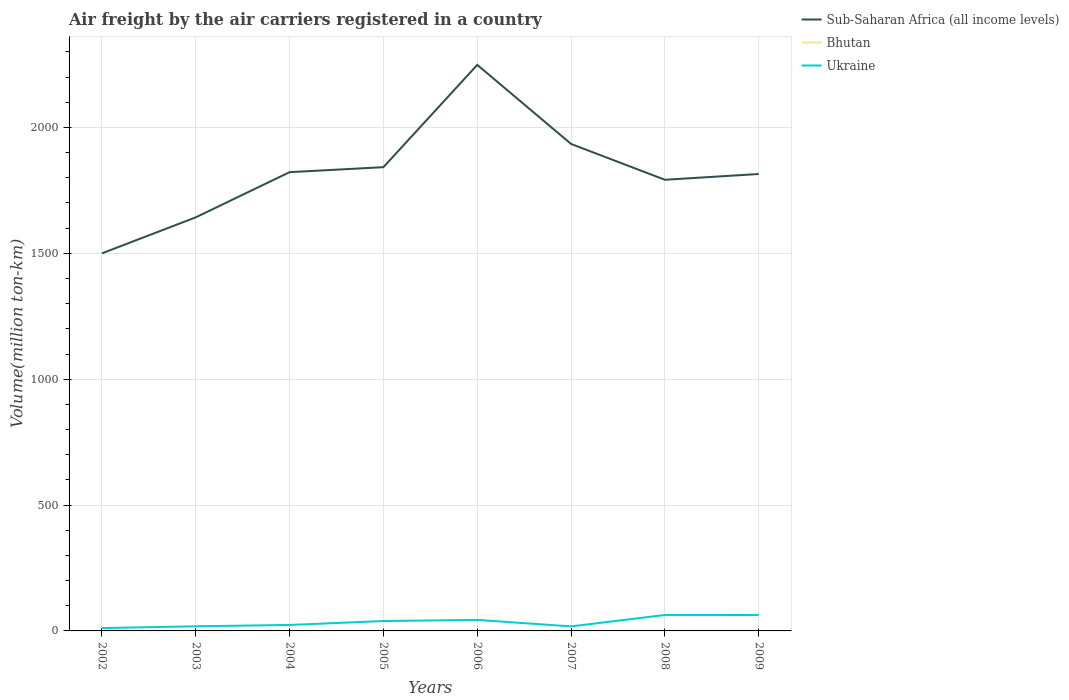Across all years, what is the maximum volume of the air carriers in Sub-Saharan Africa (all income levels)?
Offer a very short reply. 1499.87. In which year was the volume of the air carriers in Bhutan maximum?
Your answer should be compact. 2002. What is the total volume of the air carriers in Sub-Saharan Africa (all income levels) in the graph?
Offer a very short reply. -22.99. What is the difference between the highest and the second highest volume of the air carriers in Ukraine?
Provide a short and direct response. 52.08. What is the difference between the highest and the lowest volume of the air carriers in Bhutan?
Provide a short and direct response. 2. Is the volume of the air carriers in Ukraine strictly greater than the volume of the air carriers in Bhutan over the years?
Provide a succinct answer. No. How many lines are there?
Offer a very short reply. 3. How many years are there in the graph?
Provide a succinct answer. 8. Does the graph contain grids?
Provide a short and direct response. Yes. Where does the legend appear in the graph?
Your answer should be very brief. Top right. How are the legend labels stacked?
Provide a short and direct response. Vertical. What is the title of the graph?
Give a very brief answer. Air freight by the air carriers registered in a country. What is the label or title of the Y-axis?
Your response must be concise. Volume(million ton-km). What is the Volume(million ton-km) in Sub-Saharan Africa (all income levels) in 2002?
Your answer should be compact. 1499.87. What is the Volume(million ton-km) in Ukraine in 2002?
Provide a short and direct response. 11.28. What is the Volume(million ton-km) in Sub-Saharan Africa (all income levels) in 2003?
Your answer should be compact. 1642.87. What is the Volume(million ton-km) of Bhutan in 2003?
Keep it short and to the point. 0.21. What is the Volume(million ton-km) of Ukraine in 2003?
Your answer should be very brief. 18.36. What is the Volume(million ton-km) in Sub-Saharan Africa (all income levels) in 2004?
Your answer should be very brief. 1822.41. What is the Volume(million ton-km) in Bhutan in 2004?
Your answer should be compact. 0.25. What is the Volume(million ton-km) in Ukraine in 2004?
Your answer should be compact. 23.73. What is the Volume(million ton-km) of Sub-Saharan Africa (all income levels) in 2005?
Your answer should be compact. 1842.22. What is the Volume(million ton-km) of Bhutan in 2005?
Your answer should be very brief. 0.25. What is the Volume(million ton-km) in Ukraine in 2005?
Provide a short and direct response. 39.29. What is the Volume(million ton-km) in Sub-Saharan Africa (all income levels) in 2006?
Provide a succinct answer. 2248.58. What is the Volume(million ton-km) of Bhutan in 2006?
Give a very brief answer. 0.26. What is the Volume(million ton-km) in Ukraine in 2006?
Your response must be concise. 43.76. What is the Volume(million ton-km) in Sub-Saharan Africa (all income levels) in 2007?
Offer a terse response. 1934.43. What is the Volume(million ton-km) of Bhutan in 2007?
Your response must be concise. 0.28. What is the Volume(million ton-km) of Ukraine in 2007?
Provide a short and direct response. 18.01. What is the Volume(million ton-km) in Sub-Saharan Africa (all income levels) in 2008?
Make the answer very short. 1792.12. What is the Volume(million ton-km) of Bhutan in 2008?
Provide a succinct answer. 0.26. What is the Volume(million ton-km) in Ukraine in 2008?
Offer a terse response. 63.36. What is the Volume(million ton-km) of Sub-Saharan Africa (all income levels) in 2009?
Offer a terse response. 1815.11. What is the Volume(million ton-km) of Bhutan in 2009?
Give a very brief answer. 0.45. What is the Volume(million ton-km) in Ukraine in 2009?
Your response must be concise. 63.23. Across all years, what is the maximum Volume(million ton-km) in Sub-Saharan Africa (all income levels)?
Your answer should be compact. 2248.58. Across all years, what is the maximum Volume(million ton-km) in Bhutan?
Provide a succinct answer. 0.45. Across all years, what is the maximum Volume(million ton-km) of Ukraine?
Your answer should be very brief. 63.36. Across all years, what is the minimum Volume(million ton-km) in Sub-Saharan Africa (all income levels)?
Ensure brevity in your answer.  1499.87. Across all years, what is the minimum Volume(million ton-km) in Bhutan?
Make the answer very short. 0.2. Across all years, what is the minimum Volume(million ton-km) of Ukraine?
Make the answer very short. 11.28. What is the total Volume(million ton-km) of Sub-Saharan Africa (all income levels) in the graph?
Offer a terse response. 1.46e+04. What is the total Volume(million ton-km) of Bhutan in the graph?
Ensure brevity in your answer.  2.16. What is the total Volume(million ton-km) of Ukraine in the graph?
Provide a short and direct response. 281.03. What is the difference between the Volume(million ton-km) of Sub-Saharan Africa (all income levels) in 2002 and that in 2003?
Give a very brief answer. -143. What is the difference between the Volume(million ton-km) of Bhutan in 2002 and that in 2003?
Your answer should be compact. -0.01. What is the difference between the Volume(million ton-km) in Ukraine in 2002 and that in 2003?
Offer a very short reply. -7.08. What is the difference between the Volume(million ton-km) of Sub-Saharan Africa (all income levels) in 2002 and that in 2004?
Make the answer very short. -322.53. What is the difference between the Volume(million ton-km) of Bhutan in 2002 and that in 2004?
Your answer should be compact. -0.05. What is the difference between the Volume(million ton-km) of Ukraine in 2002 and that in 2004?
Keep it short and to the point. -12.45. What is the difference between the Volume(million ton-km) in Sub-Saharan Africa (all income levels) in 2002 and that in 2005?
Provide a succinct answer. -342.35. What is the difference between the Volume(million ton-km) of Bhutan in 2002 and that in 2005?
Provide a short and direct response. -0.05. What is the difference between the Volume(million ton-km) in Ukraine in 2002 and that in 2005?
Make the answer very short. -28.01. What is the difference between the Volume(million ton-km) in Sub-Saharan Africa (all income levels) in 2002 and that in 2006?
Ensure brevity in your answer.  -748.71. What is the difference between the Volume(million ton-km) in Bhutan in 2002 and that in 2006?
Offer a very short reply. -0.06. What is the difference between the Volume(million ton-km) in Ukraine in 2002 and that in 2006?
Your answer should be compact. -32.48. What is the difference between the Volume(million ton-km) of Sub-Saharan Africa (all income levels) in 2002 and that in 2007?
Provide a short and direct response. -434.56. What is the difference between the Volume(million ton-km) in Bhutan in 2002 and that in 2007?
Give a very brief answer. -0.08. What is the difference between the Volume(million ton-km) of Ukraine in 2002 and that in 2007?
Your answer should be very brief. -6.73. What is the difference between the Volume(million ton-km) in Sub-Saharan Africa (all income levels) in 2002 and that in 2008?
Provide a short and direct response. -292.24. What is the difference between the Volume(million ton-km) of Bhutan in 2002 and that in 2008?
Make the answer very short. -0.06. What is the difference between the Volume(million ton-km) in Ukraine in 2002 and that in 2008?
Your response must be concise. -52.08. What is the difference between the Volume(million ton-km) in Sub-Saharan Africa (all income levels) in 2002 and that in 2009?
Your answer should be very brief. -315.24. What is the difference between the Volume(million ton-km) of Bhutan in 2002 and that in 2009?
Offer a very short reply. -0.25. What is the difference between the Volume(million ton-km) in Ukraine in 2002 and that in 2009?
Your response must be concise. -51.95. What is the difference between the Volume(million ton-km) of Sub-Saharan Africa (all income levels) in 2003 and that in 2004?
Your response must be concise. -179.54. What is the difference between the Volume(million ton-km) in Bhutan in 2003 and that in 2004?
Ensure brevity in your answer.  -0.04. What is the difference between the Volume(million ton-km) of Ukraine in 2003 and that in 2004?
Offer a terse response. -5.38. What is the difference between the Volume(million ton-km) of Sub-Saharan Africa (all income levels) in 2003 and that in 2005?
Provide a succinct answer. -199.35. What is the difference between the Volume(million ton-km) in Bhutan in 2003 and that in 2005?
Offer a very short reply. -0.04. What is the difference between the Volume(million ton-km) in Ukraine in 2003 and that in 2005?
Give a very brief answer. -20.93. What is the difference between the Volume(million ton-km) in Sub-Saharan Africa (all income levels) in 2003 and that in 2006?
Provide a short and direct response. -605.71. What is the difference between the Volume(million ton-km) of Bhutan in 2003 and that in 2006?
Give a very brief answer. -0.05. What is the difference between the Volume(million ton-km) in Ukraine in 2003 and that in 2006?
Ensure brevity in your answer.  -25.4. What is the difference between the Volume(million ton-km) in Sub-Saharan Africa (all income levels) in 2003 and that in 2007?
Provide a succinct answer. -291.56. What is the difference between the Volume(million ton-km) of Bhutan in 2003 and that in 2007?
Give a very brief answer. -0.07. What is the difference between the Volume(million ton-km) in Ukraine in 2003 and that in 2007?
Give a very brief answer. 0.35. What is the difference between the Volume(million ton-km) of Sub-Saharan Africa (all income levels) in 2003 and that in 2008?
Give a very brief answer. -149.25. What is the difference between the Volume(million ton-km) in Bhutan in 2003 and that in 2008?
Offer a very short reply. -0.05. What is the difference between the Volume(million ton-km) of Ukraine in 2003 and that in 2008?
Offer a very short reply. -45. What is the difference between the Volume(million ton-km) of Sub-Saharan Africa (all income levels) in 2003 and that in 2009?
Provide a short and direct response. -172.24. What is the difference between the Volume(million ton-km) of Bhutan in 2003 and that in 2009?
Provide a short and direct response. -0.24. What is the difference between the Volume(million ton-km) in Ukraine in 2003 and that in 2009?
Make the answer very short. -44.87. What is the difference between the Volume(million ton-km) in Sub-Saharan Africa (all income levels) in 2004 and that in 2005?
Provide a succinct answer. -19.82. What is the difference between the Volume(million ton-km) in Bhutan in 2004 and that in 2005?
Provide a succinct answer. -0.01. What is the difference between the Volume(million ton-km) of Ukraine in 2004 and that in 2005?
Your response must be concise. -15.56. What is the difference between the Volume(million ton-km) in Sub-Saharan Africa (all income levels) in 2004 and that in 2006?
Make the answer very short. -426.18. What is the difference between the Volume(million ton-km) of Bhutan in 2004 and that in 2006?
Your answer should be compact. -0.02. What is the difference between the Volume(million ton-km) of Ukraine in 2004 and that in 2006?
Your answer should be compact. -20.03. What is the difference between the Volume(million ton-km) in Sub-Saharan Africa (all income levels) in 2004 and that in 2007?
Your response must be concise. -112.02. What is the difference between the Volume(million ton-km) in Bhutan in 2004 and that in 2007?
Ensure brevity in your answer.  -0.03. What is the difference between the Volume(million ton-km) of Ukraine in 2004 and that in 2007?
Your response must be concise. 5.72. What is the difference between the Volume(million ton-km) of Sub-Saharan Africa (all income levels) in 2004 and that in 2008?
Your answer should be very brief. 30.29. What is the difference between the Volume(million ton-km) in Bhutan in 2004 and that in 2008?
Your response must be concise. -0.02. What is the difference between the Volume(million ton-km) of Ukraine in 2004 and that in 2008?
Ensure brevity in your answer.  -39.62. What is the difference between the Volume(million ton-km) in Sub-Saharan Africa (all income levels) in 2004 and that in 2009?
Offer a very short reply. 7.3. What is the difference between the Volume(million ton-km) of Bhutan in 2004 and that in 2009?
Provide a succinct answer. -0.2. What is the difference between the Volume(million ton-km) of Ukraine in 2004 and that in 2009?
Offer a terse response. -39.5. What is the difference between the Volume(million ton-km) of Sub-Saharan Africa (all income levels) in 2005 and that in 2006?
Your response must be concise. -406.36. What is the difference between the Volume(million ton-km) of Bhutan in 2005 and that in 2006?
Make the answer very short. -0.01. What is the difference between the Volume(million ton-km) in Ukraine in 2005 and that in 2006?
Provide a succinct answer. -4.47. What is the difference between the Volume(million ton-km) of Sub-Saharan Africa (all income levels) in 2005 and that in 2007?
Provide a short and direct response. -92.2. What is the difference between the Volume(million ton-km) of Bhutan in 2005 and that in 2007?
Provide a succinct answer. -0.03. What is the difference between the Volume(million ton-km) of Ukraine in 2005 and that in 2007?
Provide a succinct answer. 21.28. What is the difference between the Volume(million ton-km) of Sub-Saharan Africa (all income levels) in 2005 and that in 2008?
Keep it short and to the point. 50.11. What is the difference between the Volume(million ton-km) of Bhutan in 2005 and that in 2008?
Provide a succinct answer. -0.01. What is the difference between the Volume(million ton-km) in Ukraine in 2005 and that in 2008?
Your answer should be very brief. -24.07. What is the difference between the Volume(million ton-km) of Sub-Saharan Africa (all income levels) in 2005 and that in 2009?
Make the answer very short. 27.11. What is the difference between the Volume(million ton-km) in Bhutan in 2005 and that in 2009?
Your answer should be very brief. -0.2. What is the difference between the Volume(million ton-km) of Ukraine in 2005 and that in 2009?
Ensure brevity in your answer.  -23.94. What is the difference between the Volume(million ton-km) in Sub-Saharan Africa (all income levels) in 2006 and that in 2007?
Make the answer very short. 314.16. What is the difference between the Volume(million ton-km) of Bhutan in 2006 and that in 2007?
Your answer should be compact. -0.02. What is the difference between the Volume(million ton-km) in Ukraine in 2006 and that in 2007?
Offer a terse response. 25.75. What is the difference between the Volume(million ton-km) of Sub-Saharan Africa (all income levels) in 2006 and that in 2008?
Make the answer very short. 456.47. What is the difference between the Volume(million ton-km) in Bhutan in 2006 and that in 2008?
Give a very brief answer. -0. What is the difference between the Volume(million ton-km) of Ukraine in 2006 and that in 2008?
Provide a short and direct response. -19.6. What is the difference between the Volume(million ton-km) in Sub-Saharan Africa (all income levels) in 2006 and that in 2009?
Your answer should be very brief. 433.48. What is the difference between the Volume(million ton-km) of Bhutan in 2006 and that in 2009?
Keep it short and to the point. -0.18. What is the difference between the Volume(million ton-km) of Ukraine in 2006 and that in 2009?
Provide a short and direct response. -19.47. What is the difference between the Volume(million ton-km) in Sub-Saharan Africa (all income levels) in 2007 and that in 2008?
Keep it short and to the point. 142.31. What is the difference between the Volume(million ton-km) of Bhutan in 2007 and that in 2008?
Ensure brevity in your answer.  0.01. What is the difference between the Volume(million ton-km) in Ukraine in 2007 and that in 2008?
Provide a short and direct response. -45.35. What is the difference between the Volume(million ton-km) in Sub-Saharan Africa (all income levels) in 2007 and that in 2009?
Your answer should be very brief. 119.32. What is the difference between the Volume(million ton-km) of Bhutan in 2007 and that in 2009?
Provide a succinct answer. -0.17. What is the difference between the Volume(million ton-km) in Ukraine in 2007 and that in 2009?
Your answer should be very brief. -45.22. What is the difference between the Volume(million ton-km) in Sub-Saharan Africa (all income levels) in 2008 and that in 2009?
Keep it short and to the point. -22.99. What is the difference between the Volume(million ton-km) in Bhutan in 2008 and that in 2009?
Provide a short and direct response. -0.18. What is the difference between the Volume(million ton-km) of Ukraine in 2008 and that in 2009?
Your answer should be compact. 0.13. What is the difference between the Volume(million ton-km) of Sub-Saharan Africa (all income levels) in 2002 and the Volume(million ton-km) of Bhutan in 2003?
Give a very brief answer. 1499.66. What is the difference between the Volume(million ton-km) of Sub-Saharan Africa (all income levels) in 2002 and the Volume(million ton-km) of Ukraine in 2003?
Keep it short and to the point. 1481.51. What is the difference between the Volume(million ton-km) of Bhutan in 2002 and the Volume(million ton-km) of Ukraine in 2003?
Ensure brevity in your answer.  -18.16. What is the difference between the Volume(million ton-km) of Sub-Saharan Africa (all income levels) in 2002 and the Volume(million ton-km) of Bhutan in 2004?
Offer a terse response. 1499.63. What is the difference between the Volume(million ton-km) in Sub-Saharan Africa (all income levels) in 2002 and the Volume(million ton-km) in Ukraine in 2004?
Give a very brief answer. 1476.14. What is the difference between the Volume(million ton-km) of Bhutan in 2002 and the Volume(million ton-km) of Ukraine in 2004?
Your answer should be very brief. -23.53. What is the difference between the Volume(million ton-km) of Sub-Saharan Africa (all income levels) in 2002 and the Volume(million ton-km) of Bhutan in 2005?
Make the answer very short. 1499.62. What is the difference between the Volume(million ton-km) in Sub-Saharan Africa (all income levels) in 2002 and the Volume(million ton-km) in Ukraine in 2005?
Your answer should be very brief. 1460.58. What is the difference between the Volume(million ton-km) of Bhutan in 2002 and the Volume(million ton-km) of Ukraine in 2005?
Your answer should be compact. -39.09. What is the difference between the Volume(million ton-km) of Sub-Saharan Africa (all income levels) in 2002 and the Volume(million ton-km) of Bhutan in 2006?
Offer a very short reply. 1499.61. What is the difference between the Volume(million ton-km) of Sub-Saharan Africa (all income levels) in 2002 and the Volume(million ton-km) of Ukraine in 2006?
Your answer should be compact. 1456.11. What is the difference between the Volume(million ton-km) of Bhutan in 2002 and the Volume(million ton-km) of Ukraine in 2006?
Offer a terse response. -43.56. What is the difference between the Volume(million ton-km) in Sub-Saharan Africa (all income levels) in 2002 and the Volume(million ton-km) in Bhutan in 2007?
Your answer should be compact. 1499.59. What is the difference between the Volume(million ton-km) in Sub-Saharan Africa (all income levels) in 2002 and the Volume(million ton-km) in Ukraine in 2007?
Give a very brief answer. 1481.86. What is the difference between the Volume(million ton-km) in Bhutan in 2002 and the Volume(million ton-km) in Ukraine in 2007?
Your answer should be very brief. -17.81. What is the difference between the Volume(million ton-km) in Sub-Saharan Africa (all income levels) in 2002 and the Volume(million ton-km) in Bhutan in 2008?
Provide a short and direct response. 1499.61. What is the difference between the Volume(million ton-km) in Sub-Saharan Africa (all income levels) in 2002 and the Volume(million ton-km) in Ukraine in 2008?
Offer a very short reply. 1436.51. What is the difference between the Volume(million ton-km) of Bhutan in 2002 and the Volume(million ton-km) of Ukraine in 2008?
Offer a terse response. -63.16. What is the difference between the Volume(million ton-km) of Sub-Saharan Africa (all income levels) in 2002 and the Volume(million ton-km) of Bhutan in 2009?
Give a very brief answer. 1499.42. What is the difference between the Volume(million ton-km) in Sub-Saharan Africa (all income levels) in 2002 and the Volume(million ton-km) in Ukraine in 2009?
Offer a very short reply. 1436.64. What is the difference between the Volume(million ton-km) in Bhutan in 2002 and the Volume(million ton-km) in Ukraine in 2009?
Offer a terse response. -63.03. What is the difference between the Volume(million ton-km) of Sub-Saharan Africa (all income levels) in 2003 and the Volume(million ton-km) of Bhutan in 2004?
Your answer should be very brief. 1642.62. What is the difference between the Volume(million ton-km) in Sub-Saharan Africa (all income levels) in 2003 and the Volume(million ton-km) in Ukraine in 2004?
Offer a very short reply. 1619.13. What is the difference between the Volume(million ton-km) in Bhutan in 2003 and the Volume(million ton-km) in Ukraine in 2004?
Ensure brevity in your answer.  -23.52. What is the difference between the Volume(million ton-km) of Sub-Saharan Africa (all income levels) in 2003 and the Volume(million ton-km) of Bhutan in 2005?
Give a very brief answer. 1642.62. What is the difference between the Volume(million ton-km) of Sub-Saharan Africa (all income levels) in 2003 and the Volume(million ton-km) of Ukraine in 2005?
Offer a very short reply. 1603.58. What is the difference between the Volume(million ton-km) of Bhutan in 2003 and the Volume(million ton-km) of Ukraine in 2005?
Your answer should be compact. -39.08. What is the difference between the Volume(million ton-km) in Sub-Saharan Africa (all income levels) in 2003 and the Volume(million ton-km) in Bhutan in 2006?
Give a very brief answer. 1642.61. What is the difference between the Volume(million ton-km) of Sub-Saharan Africa (all income levels) in 2003 and the Volume(million ton-km) of Ukraine in 2006?
Make the answer very short. 1599.11. What is the difference between the Volume(million ton-km) of Bhutan in 2003 and the Volume(million ton-km) of Ukraine in 2006?
Your answer should be very brief. -43.55. What is the difference between the Volume(million ton-km) of Sub-Saharan Africa (all income levels) in 2003 and the Volume(million ton-km) of Bhutan in 2007?
Ensure brevity in your answer.  1642.59. What is the difference between the Volume(million ton-km) of Sub-Saharan Africa (all income levels) in 2003 and the Volume(million ton-km) of Ukraine in 2007?
Offer a very short reply. 1624.86. What is the difference between the Volume(million ton-km) of Bhutan in 2003 and the Volume(million ton-km) of Ukraine in 2007?
Offer a very short reply. -17.8. What is the difference between the Volume(million ton-km) of Sub-Saharan Africa (all income levels) in 2003 and the Volume(million ton-km) of Bhutan in 2008?
Keep it short and to the point. 1642.61. What is the difference between the Volume(million ton-km) of Sub-Saharan Africa (all income levels) in 2003 and the Volume(million ton-km) of Ukraine in 2008?
Provide a short and direct response. 1579.51. What is the difference between the Volume(million ton-km) of Bhutan in 2003 and the Volume(million ton-km) of Ukraine in 2008?
Your response must be concise. -63.15. What is the difference between the Volume(million ton-km) of Sub-Saharan Africa (all income levels) in 2003 and the Volume(million ton-km) of Bhutan in 2009?
Ensure brevity in your answer.  1642.42. What is the difference between the Volume(million ton-km) in Sub-Saharan Africa (all income levels) in 2003 and the Volume(million ton-km) in Ukraine in 2009?
Your answer should be compact. 1579.64. What is the difference between the Volume(million ton-km) in Bhutan in 2003 and the Volume(million ton-km) in Ukraine in 2009?
Your answer should be very brief. -63.02. What is the difference between the Volume(million ton-km) in Sub-Saharan Africa (all income levels) in 2004 and the Volume(million ton-km) in Bhutan in 2005?
Ensure brevity in your answer.  1822.15. What is the difference between the Volume(million ton-km) of Sub-Saharan Africa (all income levels) in 2004 and the Volume(million ton-km) of Ukraine in 2005?
Your response must be concise. 1783.11. What is the difference between the Volume(million ton-km) of Bhutan in 2004 and the Volume(million ton-km) of Ukraine in 2005?
Your answer should be compact. -39.05. What is the difference between the Volume(million ton-km) of Sub-Saharan Africa (all income levels) in 2004 and the Volume(million ton-km) of Bhutan in 2006?
Keep it short and to the point. 1822.14. What is the difference between the Volume(million ton-km) in Sub-Saharan Africa (all income levels) in 2004 and the Volume(million ton-km) in Ukraine in 2006?
Your answer should be very brief. 1778.64. What is the difference between the Volume(million ton-km) of Bhutan in 2004 and the Volume(million ton-km) of Ukraine in 2006?
Offer a very short reply. -43.52. What is the difference between the Volume(million ton-km) of Sub-Saharan Africa (all income levels) in 2004 and the Volume(million ton-km) of Bhutan in 2007?
Ensure brevity in your answer.  1822.13. What is the difference between the Volume(million ton-km) of Sub-Saharan Africa (all income levels) in 2004 and the Volume(million ton-km) of Ukraine in 2007?
Your response must be concise. 1804.39. What is the difference between the Volume(million ton-km) in Bhutan in 2004 and the Volume(million ton-km) in Ukraine in 2007?
Your answer should be very brief. -17.77. What is the difference between the Volume(million ton-km) in Sub-Saharan Africa (all income levels) in 2004 and the Volume(million ton-km) in Bhutan in 2008?
Provide a succinct answer. 1822.14. What is the difference between the Volume(million ton-km) of Sub-Saharan Africa (all income levels) in 2004 and the Volume(million ton-km) of Ukraine in 2008?
Give a very brief answer. 1759.05. What is the difference between the Volume(million ton-km) of Bhutan in 2004 and the Volume(million ton-km) of Ukraine in 2008?
Provide a succinct answer. -63.11. What is the difference between the Volume(million ton-km) of Sub-Saharan Africa (all income levels) in 2004 and the Volume(million ton-km) of Bhutan in 2009?
Offer a terse response. 1821.96. What is the difference between the Volume(million ton-km) in Sub-Saharan Africa (all income levels) in 2004 and the Volume(million ton-km) in Ukraine in 2009?
Provide a short and direct response. 1759.17. What is the difference between the Volume(million ton-km) in Bhutan in 2004 and the Volume(million ton-km) in Ukraine in 2009?
Keep it short and to the point. -62.98. What is the difference between the Volume(million ton-km) of Sub-Saharan Africa (all income levels) in 2005 and the Volume(million ton-km) of Bhutan in 2006?
Provide a short and direct response. 1841.96. What is the difference between the Volume(million ton-km) in Sub-Saharan Africa (all income levels) in 2005 and the Volume(million ton-km) in Ukraine in 2006?
Offer a terse response. 1798.46. What is the difference between the Volume(million ton-km) of Bhutan in 2005 and the Volume(million ton-km) of Ukraine in 2006?
Your response must be concise. -43.51. What is the difference between the Volume(million ton-km) in Sub-Saharan Africa (all income levels) in 2005 and the Volume(million ton-km) in Bhutan in 2007?
Offer a very short reply. 1841.94. What is the difference between the Volume(million ton-km) in Sub-Saharan Africa (all income levels) in 2005 and the Volume(million ton-km) in Ukraine in 2007?
Keep it short and to the point. 1824.21. What is the difference between the Volume(million ton-km) in Bhutan in 2005 and the Volume(million ton-km) in Ukraine in 2007?
Your answer should be very brief. -17.76. What is the difference between the Volume(million ton-km) of Sub-Saharan Africa (all income levels) in 2005 and the Volume(million ton-km) of Bhutan in 2008?
Your answer should be very brief. 1841.96. What is the difference between the Volume(million ton-km) of Sub-Saharan Africa (all income levels) in 2005 and the Volume(million ton-km) of Ukraine in 2008?
Keep it short and to the point. 1778.86. What is the difference between the Volume(million ton-km) of Bhutan in 2005 and the Volume(million ton-km) of Ukraine in 2008?
Give a very brief answer. -63.11. What is the difference between the Volume(million ton-km) of Sub-Saharan Africa (all income levels) in 2005 and the Volume(million ton-km) of Bhutan in 2009?
Your answer should be compact. 1841.77. What is the difference between the Volume(million ton-km) of Sub-Saharan Africa (all income levels) in 2005 and the Volume(million ton-km) of Ukraine in 2009?
Ensure brevity in your answer.  1778.99. What is the difference between the Volume(million ton-km) of Bhutan in 2005 and the Volume(million ton-km) of Ukraine in 2009?
Your response must be concise. -62.98. What is the difference between the Volume(million ton-km) in Sub-Saharan Africa (all income levels) in 2006 and the Volume(million ton-km) in Bhutan in 2007?
Your answer should be compact. 2248.3. What is the difference between the Volume(million ton-km) of Sub-Saharan Africa (all income levels) in 2006 and the Volume(million ton-km) of Ukraine in 2007?
Provide a succinct answer. 2230.57. What is the difference between the Volume(million ton-km) in Bhutan in 2006 and the Volume(million ton-km) in Ukraine in 2007?
Offer a very short reply. -17.75. What is the difference between the Volume(million ton-km) in Sub-Saharan Africa (all income levels) in 2006 and the Volume(million ton-km) in Bhutan in 2008?
Offer a very short reply. 2248.32. What is the difference between the Volume(million ton-km) of Sub-Saharan Africa (all income levels) in 2006 and the Volume(million ton-km) of Ukraine in 2008?
Your answer should be very brief. 2185.22. What is the difference between the Volume(million ton-km) in Bhutan in 2006 and the Volume(million ton-km) in Ukraine in 2008?
Make the answer very short. -63.1. What is the difference between the Volume(million ton-km) in Sub-Saharan Africa (all income levels) in 2006 and the Volume(million ton-km) in Bhutan in 2009?
Your response must be concise. 2248.14. What is the difference between the Volume(million ton-km) of Sub-Saharan Africa (all income levels) in 2006 and the Volume(million ton-km) of Ukraine in 2009?
Offer a terse response. 2185.35. What is the difference between the Volume(million ton-km) in Bhutan in 2006 and the Volume(million ton-km) in Ukraine in 2009?
Offer a very short reply. -62.97. What is the difference between the Volume(million ton-km) in Sub-Saharan Africa (all income levels) in 2007 and the Volume(million ton-km) in Bhutan in 2008?
Your response must be concise. 1934.16. What is the difference between the Volume(million ton-km) of Sub-Saharan Africa (all income levels) in 2007 and the Volume(million ton-km) of Ukraine in 2008?
Offer a very short reply. 1871.07. What is the difference between the Volume(million ton-km) of Bhutan in 2007 and the Volume(million ton-km) of Ukraine in 2008?
Make the answer very short. -63.08. What is the difference between the Volume(million ton-km) in Sub-Saharan Africa (all income levels) in 2007 and the Volume(million ton-km) in Bhutan in 2009?
Make the answer very short. 1933.98. What is the difference between the Volume(million ton-km) of Sub-Saharan Africa (all income levels) in 2007 and the Volume(million ton-km) of Ukraine in 2009?
Make the answer very short. 1871.2. What is the difference between the Volume(million ton-km) of Bhutan in 2007 and the Volume(million ton-km) of Ukraine in 2009?
Your answer should be very brief. -62.95. What is the difference between the Volume(million ton-km) of Sub-Saharan Africa (all income levels) in 2008 and the Volume(million ton-km) of Bhutan in 2009?
Ensure brevity in your answer.  1791.67. What is the difference between the Volume(million ton-km) of Sub-Saharan Africa (all income levels) in 2008 and the Volume(million ton-km) of Ukraine in 2009?
Ensure brevity in your answer.  1728.88. What is the difference between the Volume(million ton-km) of Bhutan in 2008 and the Volume(million ton-km) of Ukraine in 2009?
Your answer should be compact. -62.97. What is the average Volume(million ton-km) of Sub-Saharan Africa (all income levels) per year?
Provide a short and direct response. 1824.7. What is the average Volume(million ton-km) of Bhutan per year?
Provide a short and direct response. 0.27. What is the average Volume(million ton-km) in Ukraine per year?
Ensure brevity in your answer.  35.13. In the year 2002, what is the difference between the Volume(million ton-km) of Sub-Saharan Africa (all income levels) and Volume(million ton-km) of Bhutan?
Keep it short and to the point. 1499.67. In the year 2002, what is the difference between the Volume(million ton-km) in Sub-Saharan Africa (all income levels) and Volume(million ton-km) in Ukraine?
Make the answer very short. 1488.59. In the year 2002, what is the difference between the Volume(million ton-km) of Bhutan and Volume(million ton-km) of Ukraine?
Provide a succinct answer. -11.08. In the year 2003, what is the difference between the Volume(million ton-km) of Sub-Saharan Africa (all income levels) and Volume(million ton-km) of Bhutan?
Offer a very short reply. 1642.66. In the year 2003, what is the difference between the Volume(million ton-km) in Sub-Saharan Africa (all income levels) and Volume(million ton-km) in Ukraine?
Keep it short and to the point. 1624.51. In the year 2003, what is the difference between the Volume(million ton-km) in Bhutan and Volume(million ton-km) in Ukraine?
Your response must be concise. -18.15. In the year 2004, what is the difference between the Volume(million ton-km) in Sub-Saharan Africa (all income levels) and Volume(million ton-km) in Bhutan?
Provide a succinct answer. 1822.16. In the year 2004, what is the difference between the Volume(million ton-km) in Sub-Saharan Africa (all income levels) and Volume(million ton-km) in Ukraine?
Make the answer very short. 1798.67. In the year 2004, what is the difference between the Volume(million ton-km) of Bhutan and Volume(million ton-km) of Ukraine?
Give a very brief answer. -23.49. In the year 2005, what is the difference between the Volume(million ton-km) of Sub-Saharan Africa (all income levels) and Volume(million ton-km) of Bhutan?
Make the answer very short. 1841.97. In the year 2005, what is the difference between the Volume(million ton-km) of Sub-Saharan Africa (all income levels) and Volume(million ton-km) of Ukraine?
Make the answer very short. 1802.93. In the year 2005, what is the difference between the Volume(million ton-km) in Bhutan and Volume(million ton-km) in Ukraine?
Provide a succinct answer. -39.04. In the year 2006, what is the difference between the Volume(million ton-km) in Sub-Saharan Africa (all income levels) and Volume(million ton-km) in Bhutan?
Offer a very short reply. 2248.32. In the year 2006, what is the difference between the Volume(million ton-km) in Sub-Saharan Africa (all income levels) and Volume(million ton-km) in Ukraine?
Your answer should be compact. 2204.82. In the year 2006, what is the difference between the Volume(million ton-km) of Bhutan and Volume(million ton-km) of Ukraine?
Give a very brief answer. -43.5. In the year 2007, what is the difference between the Volume(million ton-km) in Sub-Saharan Africa (all income levels) and Volume(million ton-km) in Bhutan?
Provide a succinct answer. 1934.15. In the year 2007, what is the difference between the Volume(million ton-km) in Sub-Saharan Africa (all income levels) and Volume(million ton-km) in Ukraine?
Your response must be concise. 1916.41. In the year 2007, what is the difference between the Volume(million ton-km) of Bhutan and Volume(million ton-km) of Ukraine?
Your answer should be very brief. -17.73. In the year 2008, what is the difference between the Volume(million ton-km) in Sub-Saharan Africa (all income levels) and Volume(million ton-km) in Bhutan?
Keep it short and to the point. 1791.85. In the year 2008, what is the difference between the Volume(million ton-km) in Sub-Saharan Africa (all income levels) and Volume(million ton-km) in Ukraine?
Provide a short and direct response. 1728.76. In the year 2008, what is the difference between the Volume(million ton-km) in Bhutan and Volume(million ton-km) in Ukraine?
Give a very brief answer. -63.09. In the year 2009, what is the difference between the Volume(million ton-km) in Sub-Saharan Africa (all income levels) and Volume(million ton-km) in Bhutan?
Your answer should be very brief. 1814.66. In the year 2009, what is the difference between the Volume(million ton-km) in Sub-Saharan Africa (all income levels) and Volume(million ton-km) in Ukraine?
Your response must be concise. 1751.88. In the year 2009, what is the difference between the Volume(million ton-km) of Bhutan and Volume(million ton-km) of Ukraine?
Ensure brevity in your answer.  -62.78. What is the ratio of the Volume(million ton-km) in Sub-Saharan Africa (all income levels) in 2002 to that in 2003?
Offer a terse response. 0.91. What is the ratio of the Volume(million ton-km) of Ukraine in 2002 to that in 2003?
Your answer should be compact. 0.61. What is the ratio of the Volume(million ton-km) in Sub-Saharan Africa (all income levels) in 2002 to that in 2004?
Your answer should be very brief. 0.82. What is the ratio of the Volume(million ton-km) of Bhutan in 2002 to that in 2004?
Make the answer very short. 0.81. What is the ratio of the Volume(million ton-km) of Ukraine in 2002 to that in 2004?
Offer a very short reply. 0.48. What is the ratio of the Volume(million ton-km) in Sub-Saharan Africa (all income levels) in 2002 to that in 2005?
Your response must be concise. 0.81. What is the ratio of the Volume(million ton-km) of Bhutan in 2002 to that in 2005?
Give a very brief answer. 0.79. What is the ratio of the Volume(million ton-km) in Ukraine in 2002 to that in 2005?
Keep it short and to the point. 0.29. What is the ratio of the Volume(million ton-km) of Sub-Saharan Africa (all income levels) in 2002 to that in 2006?
Ensure brevity in your answer.  0.67. What is the ratio of the Volume(million ton-km) in Bhutan in 2002 to that in 2006?
Offer a terse response. 0.76. What is the ratio of the Volume(million ton-km) in Ukraine in 2002 to that in 2006?
Your answer should be compact. 0.26. What is the ratio of the Volume(million ton-km) of Sub-Saharan Africa (all income levels) in 2002 to that in 2007?
Offer a terse response. 0.78. What is the ratio of the Volume(million ton-km) in Bhutan in 2002 to that in 2007?
Provide a succinct answer. 0.72. What is the ratio of the Volume(million ton-km) in Ukraine in 2002 to that in 2007?
Give a very brief answer. 0.63. What is the ratio of the Volume(million ton-km) in Sub-Saharan Africa (all income levels) in 2002 to that in 2008?
Offer a very short reply. 0.84. What is the ratio of the Volume(million ton-km) in Bhutan in 2002 to that in 2008?
Your answer should be very brief. 0.76. What is the ratio of the Volume(million ton-km) in Ukraine in 2002 to that in 2008?
Provide a succinct answer. 0.18. What is the ratio of the Volume(million ton-km) of Sub-Saharan Africa (all income levels) in 2002 to that in 2009?
Your response must be concise. 0.83. What is the ratio of the Volume(million ton-km) of Bhutan in 2002 to that in 2009?
Provide a short and direct response. 0.45. What is the ratio of the Volume(million ton-km) in Ukraine in 2002 to that in 2009?
Give a very brief answer. 0.18. What is the ratio of the Volume(million ton-km) of Sub-Saharan Africa (all income levels) in 2003 to that in 2004?
Ensure brevity in your answer.  0.9. What is the ratio of the Volume(million ton-km) in Bhutan in 2003 to that in 2004?
Offer a very short reply. 0.85. What is the ratio of the Volume(million ton-km) of Ukraine in 2003 to that in 2004?
Your answer should be compact. 0.77. What is the ratio of the Volume(million ton-km) in Sub-Saharan Africa (all income levels) in 2003 to that in 2005?
Your answer should be compact. 0.89. What is the ratio of the Volume(million ton-km) in Bhutan in 2003 to that in 2005?
Your answer should be compact. 0.83. What is the ratio of the Volume(million ton-km) in Ukraine in 2003 to that in 2005?
Your answer should be compact. 0.47. What is the ratio of the Volume(million ton-km) of Sub-Saharan Africa (all income levels) in 2003 to that in 2006?
Make the answer very short. 0.73. What is the ratio of the Volume(million ton-km) in Bhutan in 2003 to that in 2006?
Provide a succinct answer. 0.8. What is the ratio of the Volume(million ton-km) of Ukraine in 2003 to that in 2006?
Your answer should be very brief. 0.42. What is the ratio of the Volume(million ton-km) in Sub-Saharan Africa (all income levels) in 2003 to that in 2007?
Provide a succinct answer. 0.85. What is the ratio of the Volume(million ton-km) in Bhutan in 2003 to that in 2007?
Your answer should be compact. 0.75. What is the ratio of the Volume(million ton-km) in Ukraine in 2003 to that in 2007?
Provide a short and direct response. 1.02. What is the ratio of the Volume(million ton-km) in Bhutan in 2003 to that in 2008?
Keep it short and to the point. 0.8. What is the ratio of the Volume(million ton-km) of Ukraine in 2003 to that in 2008?
Ensure brevity in your answer.  0.29. What is the ratio of the Volume(million ton-km) of Sub-Saharan Africa (all income levels) in 2003 to that in 2009?
Your response must be concise. 0.91. What is the ratio of the Volume(million ton-km) of Bhutan in 2003 to that in 2009?
Offer a terse response. 0.47. What is the ratio of the Volume(million ton-km) in Ukraine in 2003 to that in 2009?
Offer a terse response. 0.29. What is the ratio of the Volume(million ton-km) of Sub-Saharan Africa (all income levels) in 2004 to that in 2005?
Make the answer very short. 0.99. What is the ratio of the Volume(million ton-km) in Bhutan in 2004 to that in 2005?
Provide a short and direct response. 0.97. What is the ratio of the Volume(million ton-km) of Ukraine in 2004 to that in 2005?
Offer a terse response. 0.6. What is the ratio of the Volume(million ton-km) in Sub-Saharan Africa (all income levels) in 2004 to that in 2006?
Provide a succinct answer. 0.81. What is the ratio of the Volume(million ton-km) of Bhutan in 2004 to that in 2006?
Your answer should be very brief. 0.94. What is the ratio of the Volume(million ton-km) of Ukraine in 2004 to that in 2006?
Provide a short and direct response. 0.54. What is the ratio of the Volume(million ton-km) of Sub-Saharan Africa (all income levels) in 2004 to that in 2007?
Keep it short and to the point. 0.94. What is the ratio of the Volume(million ton-km) in Bhutan in 2004 to that in 2007?
Your answer should be very brief. 0.88. What is the ratio of the Volume(million ton-km) in Ukraine in 2004 to that in 2007?
Provide a short and direct response. 1.32. What is the ratio of the Volume(million ton-km) of Sub-Saharan Africa (all income levels) in 2004 to that in 2008?
Your answer should be very brief. 1.02. What is the ratio of the Volume(million ton-km) of Bhutan in 2004 to that in 2008?
Make the answer very short. 0.93. What is the ratio of the Volume(million ton-km) of Ukraine in 2004 to that in 2008?
Offer a terse response. 0.37. What is the ratio of the Volume(million ton-km) of Sub-Saharan Africa (all income levels) in 2004 to that in 2009?
Provide a succinct answer. 1. What is the ratio of the Volume(million ton-km) of Bhutan in 2004 to that in 2009?
Your answer should be very brief. 0.55. What is the ratio of the Volume(million ton-km) in Ukraine in 2004 to that in 2009?
Make the answer very short. 0.38. What is the ratio of the Volume(million ton-km) of Sub-Saharan Africa (all income levels) in 2005 to that in 2006?
Provide a succinct answer. 0.82. What is the ratio of the Volume(million ton-km) in Bhutan in 2005 to that in 2006?
Your answer should be compact. 0.96. What is the ratio of the Volume(million ton-km) of Ukraine in 2005 to that in 2006?
Make the answer very short. 0.9. What is the ratio of the Volume(million ton-km) of Sub-Saharan Africa (all income levels) in 2005 to that in 2007?
Offer a very short reply. 0.95. What is the ratio of the Volume(million ton-km) in Bhutan in 2005 to that in 2007?
Provide a short and direct response. 0.91. What is the ratio of the Volume(million ton-km) of Ukraine in 2005 to that in 2007?
Ensure brevity in your answer.  2.18. What is the ratio of the Volume(million ton-km) in Sub-Saharan Africa (all income levels) in 2005 to that in 2008?
Keep it short and to the point. 1.03. What is the ratio of the Volume(million ton-km) in Ukraine in 2005 to that in 2008?
Keep it short and to the point. 0.62. What is the ratio of the Volume(million ton-km) of Sub-Saharan Africa (all income levels) in 2005 to that in 2009?
Your response must be concise. 1.01. What is the ratio of the Volume(million ton-km) in Bhutan in 2005 to that in 2009?
Keep it short and to the point. 0.56. What is the ratio of the Volume(million ton-km) of Ukraine in 2005 to that in 2009?
Keep it short and to the point. 0.62. What is the ratio of the Volume(million ton-km) in Sub-Saharan Africa (all income levels) in 2006 to that in 2007?
Keep it short and to the point. 1.16. What is the ratio of the Volume(million ton-km) in Bhutan in 2006 to that in 2007?
Give a very brief answer. 0.94. What is the ratio of the Volume(million ton-km) of Ukraine in 2006 to that in 2007?
Your response must be concise. 2.43. What is the ratio of the Volume(million ton-km) in Sub-Saharan Africa (all income levels) in 2006 to that in 2008?
Your response must be concise. 1.25. What is the ratio of the Volume(million ton-km) in Ukraine in 2006 to that in 2008?
Offer a very short reply. 0.69. What is the ratio of the Volume(million ton-km) of Sub-Saharan Africa (all income levels) in 2006 to that in 2009?
Provide a short and direct response. 1.24. What is the ratio of the Volume(million ton-km) in Bhutan in 2006 to that in 2009?
Your answer should be very brief. 0.59. What is the ratio of the Volume(million ton-km) of Ukraine in 2006 to that in 2009?
Ensure brevity in your answer.  0.69. What is the ratio of the Volume(million ton-km) of Sub-Saharan Africa (all income levels) in 2007 to that in 2008?
Ensure brevity in your answer.  1.08. What is the ratio of the Volume(million ton-km) in Bhutan in 2007 to that in 2008?
Keep it short and to the point. 1.06. What is the ratio of the Volume(million ton-km) of Ukraine in 2007 to that in 2008?
Keep it short and to the point. 0.28. What is the ratio of the Volume(million ton-km) of Sub-Saharan Africa (all income levels) in 2007 to that in 2009?
Offer a very short reply. 1.07. What is the ratio of the Volume(million ton-km) in Bhutan in 2007 to that in 2009?
Make the answer very short. 0.62. What is the ratio of the Volume(million ton-km) of Ukraine in 2007 to that in 2009?
Provide a short and direct response. 0.28. What is the ratio of the Volume(million ton-km) of Sub-Saharan Africa (all income levels) in 2008 to that in 2009?
Keep it short and to the point. 0.99. What is the ratio of the Volume(million ton-km) of Bhutan in 2008 to that in 2009?
Keep it short and to the point. 0.59. What is the ratio of the Volume(million ton-km) in Ukraine in 2008 to that in 2009?
Your answer should be very brief. 1. What is the difference between the highest and the second highest Volume(million ton-km) of Sub-Saharan Africa (all income levels)?
Ensure brevity in your answer.  314.16. What is the difference between the highest and the second highest Volume(million ton-km) of Bhutan?
Ensure brevity in your answer.  0.17. What is the difference between the highest and the second highest Volume(million ton-km) of Ukraine?
Offer a very short reply. 0.13. What is the difference between the highest and the lowest Volume(million ton-km) in Sub-Saharan Africa (all income levels)?
Keep it short and to the point. 748.71. What is the difference between the highest and the lowest Volume(million ton-km) in Bhutan?
Provide a short and direct response. 0.25. What is the difference between the highest and the lowest Volume(million ton-km) of Ukraine?
Make the answer very short. 52.08. 